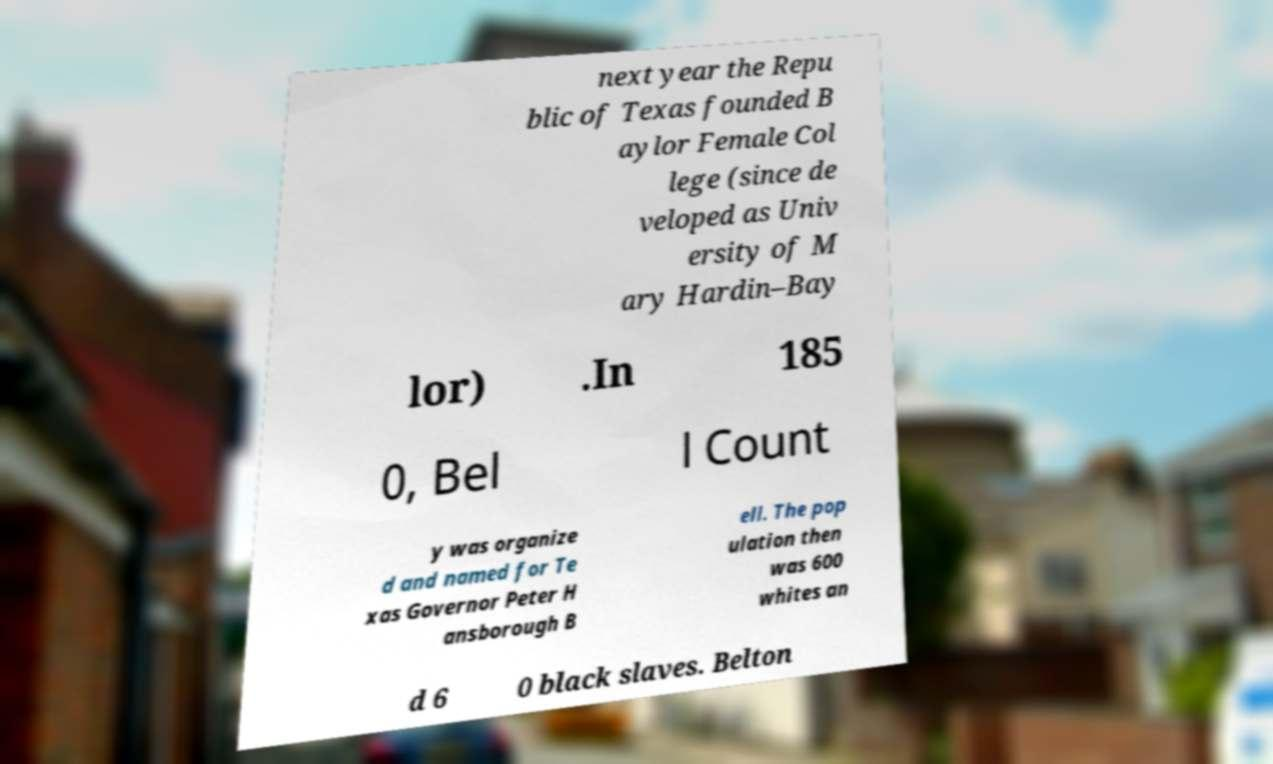There's text embedded in this image that I need extracted. Can you transcribe it verbatim? next year the Repu blic of Texas founded B aylor Female Col lege (since de veloped as Univ ersity of M ary Hardin–Bay lor) .In 185 0, Bel l Count y was organize d and named for Te xas Governor Peter H ansborough B ell. The pop ulation then was 600 whites an d 6 0 black slaves. Belton 